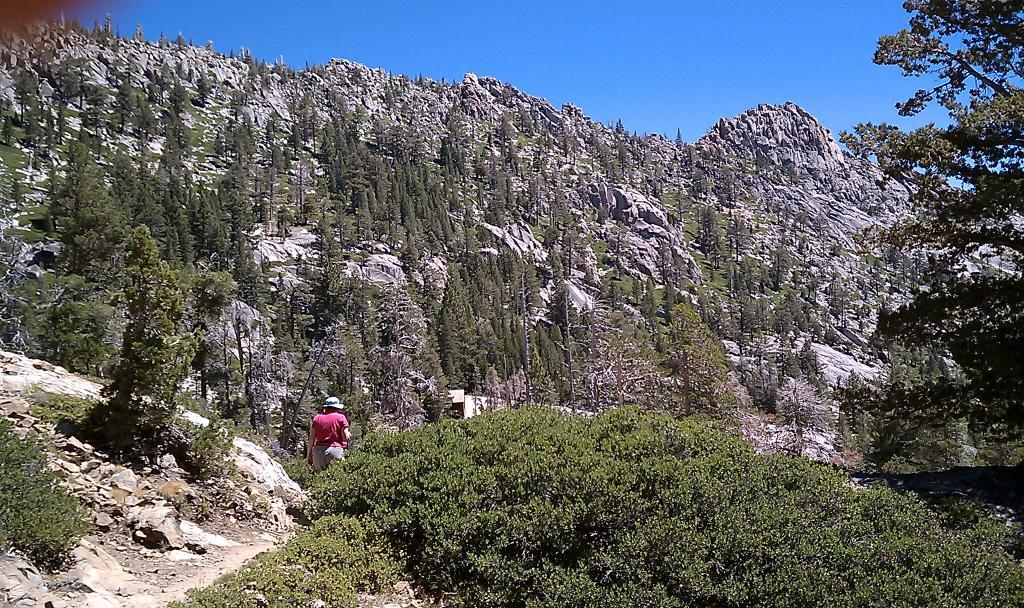What type of vegetation is present in the image? There are green trees in the image. What natural landforms can be seen in the image? There are mountains in the image. What type of ground surface is visible in the image? There are stones in the image. What is the person in the image doing? A person is walking in the image. What is the color of the sky in the image? The sky is blue in color. What type of fear can be seen on the faces of the trees in the image? There is no fear present on the trees in the image, as trees do not have emotions or the ability to express fear. 